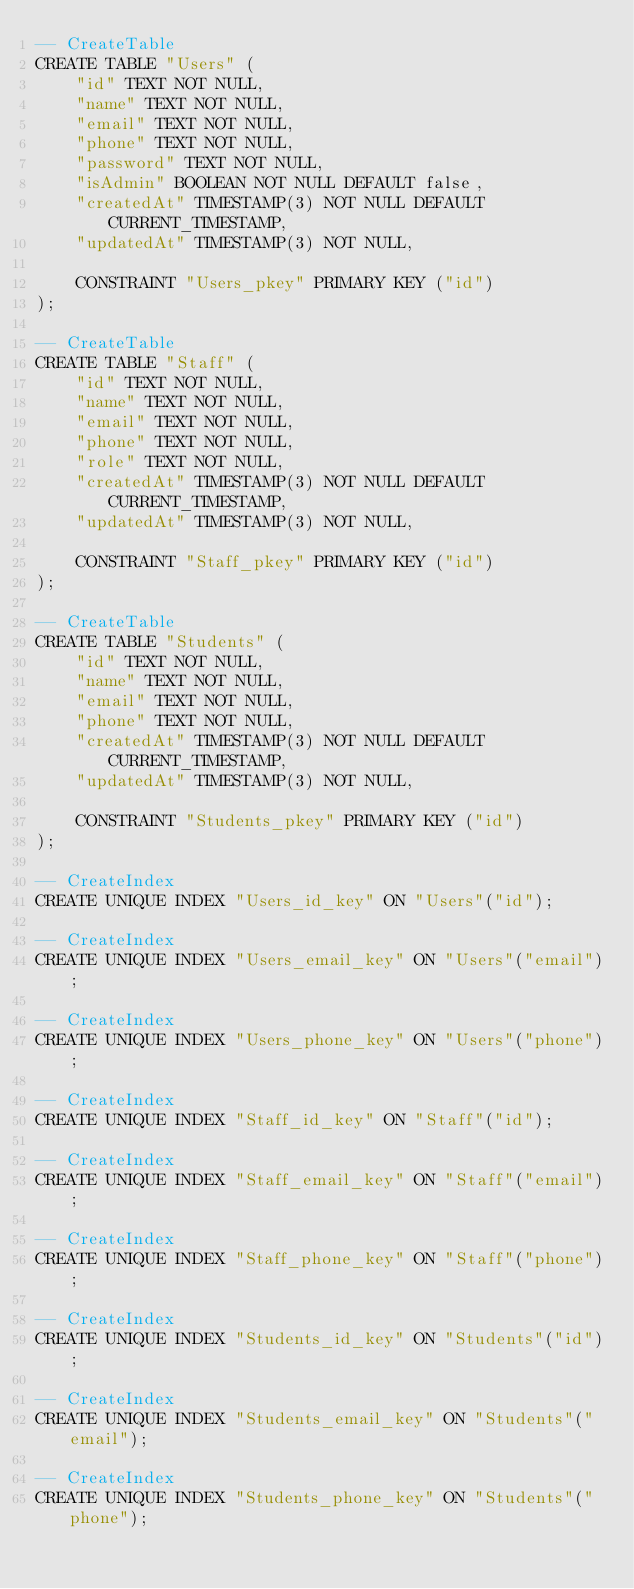Convert code to text. <code><loc_0><loc_0><loc_500><loc_500><_SQL_>-- CreateTable
CREATE TABLE "Users" (
    "id" TEXT NOT NULL,
    "name" TEXT NOT NULL,
    "email" TEXT NOT NULL,
    "phone" TEXT NOT NULL,
    "password" TEXT NOT NULL,
    "isAdmin" BOOLEAN NOT NULL DEFAULT false,
    "createdAt" TIMESTAMP(3) NOT NULL DEFAULT CURRENT_TIMESTAMP,
    "updatedAt" TIMESTAMP(3) NOT NULL,

    CONSTRAINT "Users_pkey" PRIMARY KEY ("id")
);

-- CreateTable
CREATE TABLE "Staff" (
    "id" TEXT NOT NULL,
    "name" TEXT NOT NULL,
    "email" TEXT NOT NULL,
    "phone" TEXT NOT NULL,
    "role" TEXT NOT NULL,
    "createdAt" TIMESTAMP(3) NOT NULL DEFAULT CURRENT_TIMESTAMP,
    "updatedAt" TIMESTAMP(3) NOT NULL,

    CONSTRAINT "Staff_pkey" PRIMARY KEY ("id")
);

-- CreateTable
CREATE TABLE "Students" (
    "id" TEXT NOT NULL,
    "name" TEXT NOT NULL,
    "email" TEXT NOT NULL,
    "phone" TEXT NOT NULL,
    "createdAt" TIMESTAMP(3) NOT NULL DEFAULT CURRENT_TIMESTAMP,
    "updatedAt" TIMESTAMP(3) NOT NULL,

    CONSTRAINT "Students_pkey" PRIMARY KEY ("id")
);

-- CreateIndex
CREATE UNIQUE INDEX "Users_id_key" ON "Users"("id");

-- CreateIndex
CREATE UNIQUE INDEX "Users_email_key" ON "Users"("email");

-- CreateIndex
CREATE UNIQUE INDEX "Users_phone_key" ON "Users"("phone");

-- CreateIndex
CREATE UNIQUE INDEX "Staff_id_key" ON "Staff"("id");

-- CreateIndex
CREATE UNIQUE INDEX "Staff_email_key" ON "Staff"("email");

-- CreateIndex
CREATE UNIQUE INDEX "Staff_phone_key" ON "Staff"("phone");

-- CreateIndex
CREATE UNIQUE INDEX "Students_id_key" ON "Students"("id");

-- CreateIndex
CREATE UNIQUE INDEX "Students_email_key" ON "Students"("email");

-- CreateIndex
CREATE UNIQUE INDEX "Students_phone_key" ON "Students"("phone");
</code> 